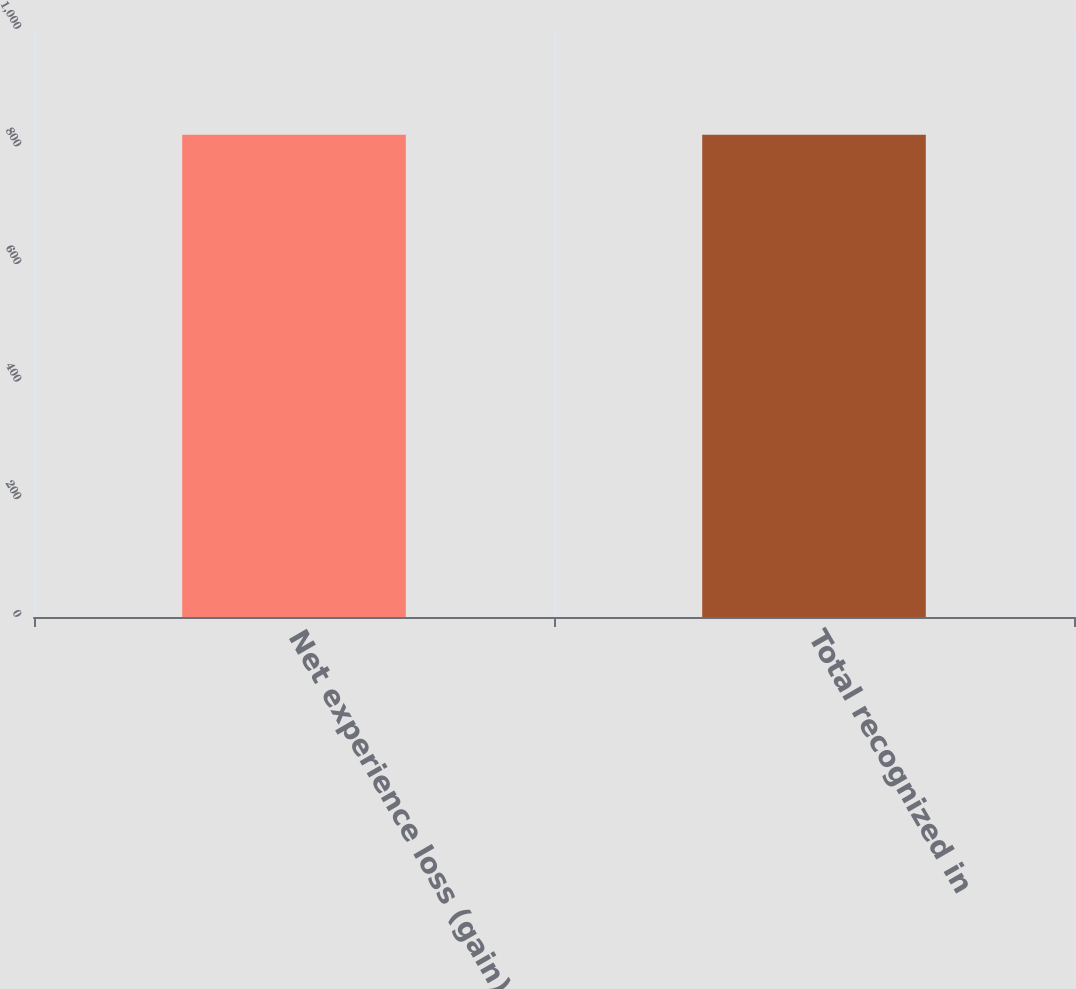<chart> <loc_0><loc_0><loc_500><loc_500><bar_chart><fcel>Net experience loss (gain)<fcel>Total recognized in<nl><fcel>820<fcel>820.1<nl></chart> 